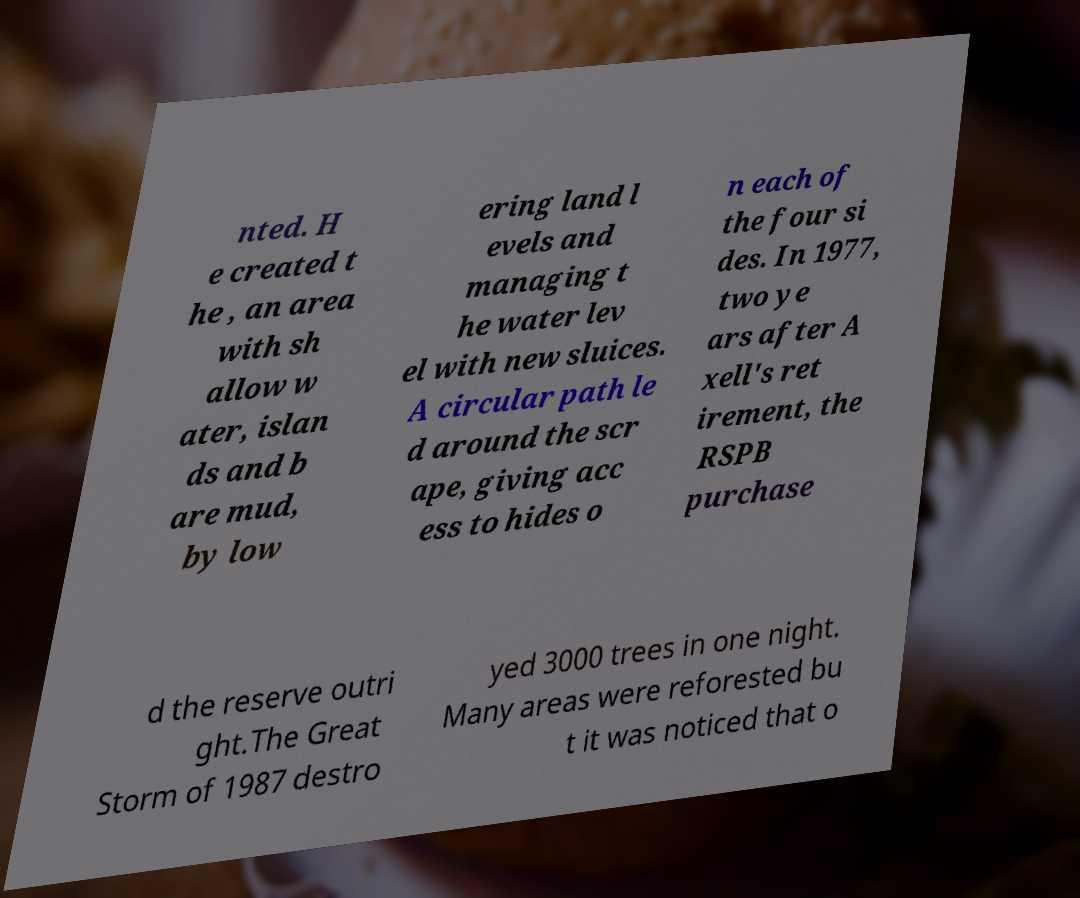For documentation purposes, I need the text within this image transcribed. Could you provide that? nted. H e created t he , an area with sh allow w ater, islan ds and b are mud, by low ering land l evels and managing t he water lev el with new sluices. A circular path le d around the scr ape, giving acc ess to hides o n each of the four si des. In 1977, two ye ars after A xell's ret irement, the RSPB purchase d the reserve outri ght.The Great Storm of 1987 destro yed 3000 trees in one night. Many areas were reforested bu t it was noticed that o 